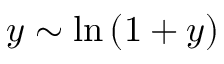Convert formula to latex. <formula><loc_0><loc_0><loc_500><loc_500>y \sim \ln { ( 1 + y ) }</formula> 